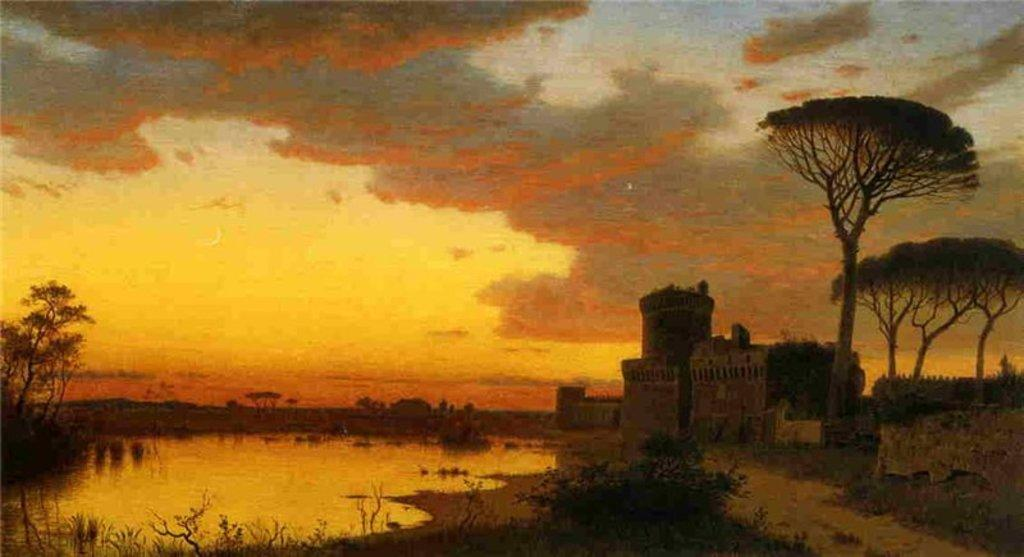What structure is located on the right side of the image? There is a house on the right side of the image. What type of vegetation is on the left side of the image? There are trees on the left side of the image. What type of vegetation is on the right side of the image? There are trees on the right side of the image. What body of water is present in the image? There is a pond in the image. What is visible at the top of the image? The sky is visible in the image. What can be seen in the sky? Clouds are present in the sky. Where is the light bulb located in the image? There is no light bulb present in the image. What type of crops are growing in the field in the image? There is no field present in the image. 